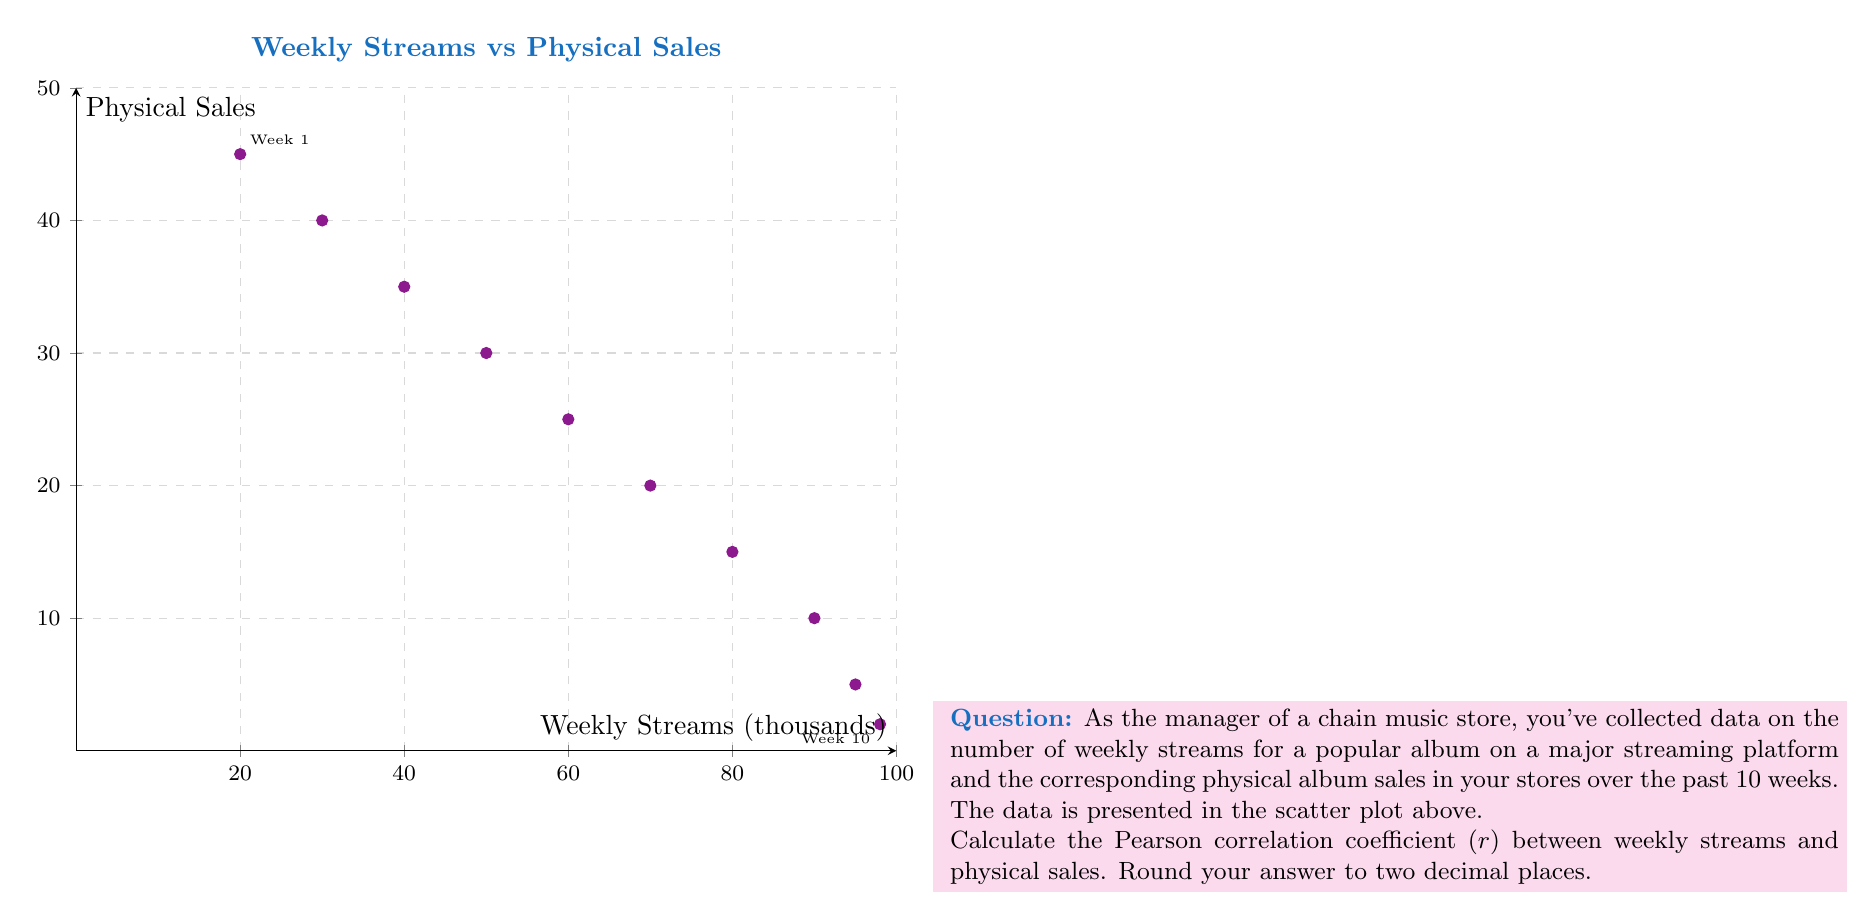Can you answer this question? To calculate the Pearson correlation coefficient, we'll follow these steps:

1) First, let's organize our data:
   x (streams in thousands): 20, 30, 40, 50, 60, 70, 80, 90, 95, 98
   y (physical sales): 45, 40, 35, 30, 25, 20, 15, 10, 5, 2

2) Calculate the means:
   $\bar{x} = \frac{633}{10} = 63.3$
   $\bar{y} = \frac{227}{10} = 22.7$

3) Calculate the standard deviations:
   $s_x = \sqrt{\frac{\sum(x_i - \bar{x})^2}{n-1}} = 28.11$
   $s_y = \sqrt{\frac{\sum(y_i - \bar{y})^2}{n-1}} = 15.19$

4) Calculate the covariance:
   $cov(x,y) = \frac{\sum(x_i - \bar{x})(y_i - \bar{y})}{n-1} = -422.23$

5) Apply the formula for Pearson correlation coefficient:
   $$r = \frac{cov(x,y)}{s_x s_y} = \frac{-422.23}{28.11 * 15.19} = -0.9896$$

6) Round to two decimal places: -0.99

The strong negative correlation indicates that as streaming numbers increase, physical sales decrease significantly.
Answer: $r = -0.99$ 